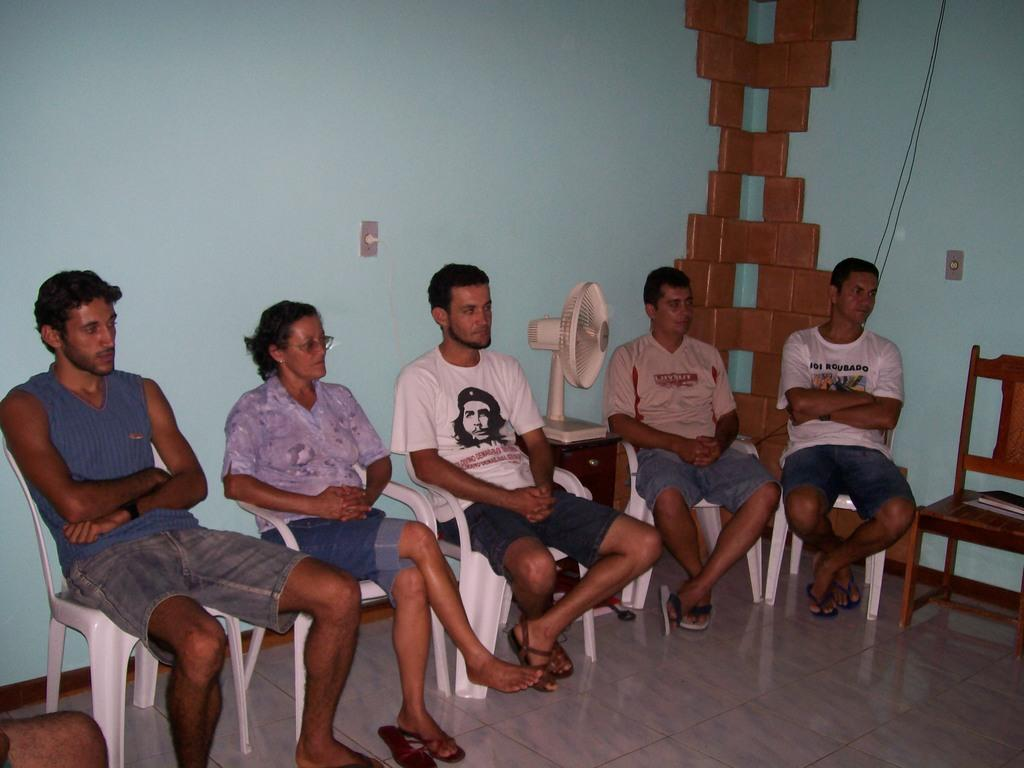How many people are in the image? There are five persons in the image. What are the persons doing in the image? The persons are sitting on chairs. What is in the middle of the image? There is a table in the middle of the image. What is placed on the table? A fan is present on the table. What can be seen behind the persons? There is a wall behind the persons. What is the color of the floor in the image? The floor is white in color. What time of day is it in the image? The time of day cannot be determined from the image, as there are no clues or indicators present. 